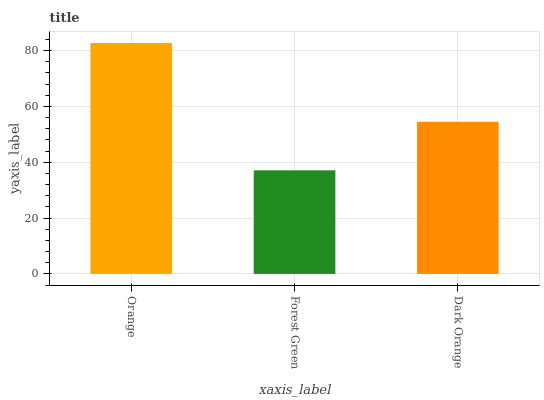Is Forest Green the minimum?
Answer yes or no. Yes. Is Orange the maximum?
Answer yes or no. Yes. Is Dark Orange the minimum?
Answer yes or no. No. Is Dark Orange the maximum?
Answer yes or no. No. Is Dark Orange greater than Forest Green?
Answer yes or no. Yes. Is Forest Green less than Dark Orange?
Answer yes or no. Yes. Is Forest Green greater than Dark Orange?
Answer yes or no. No. Is Dark Orange less than Forest Green?
Answer yes or no. No. Is Dark Orange the high median?
Answer yes or no. Yes. Is Dark Orange the low median?
Answer yes or no. Yes. Is Forest Green the high median?
Answer yes or no. No. Is Orange the low median?
Answer yes or no. No. 